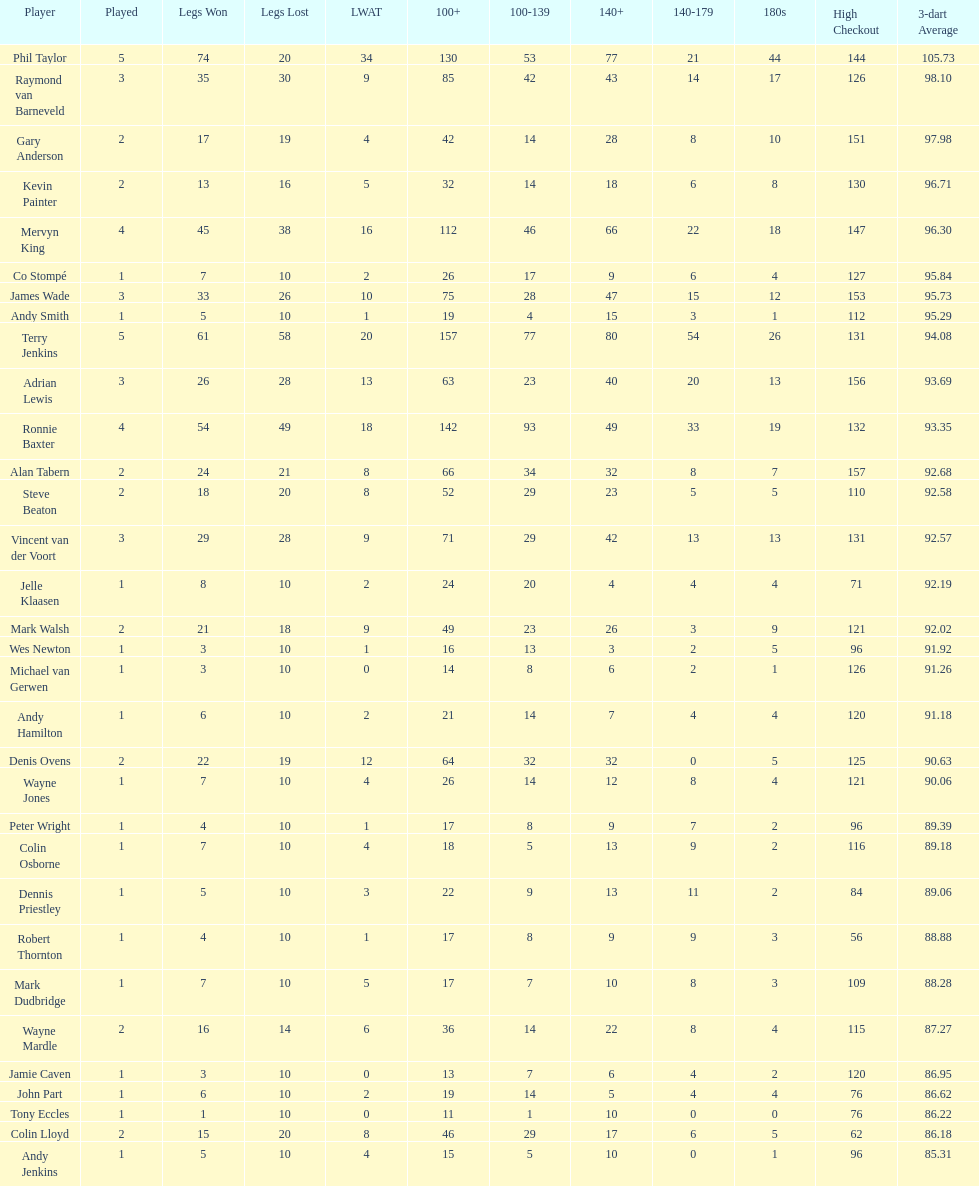Enumerate all the players with a high checkout of 13 Terry Jenkins, Vincent van der Voort. 